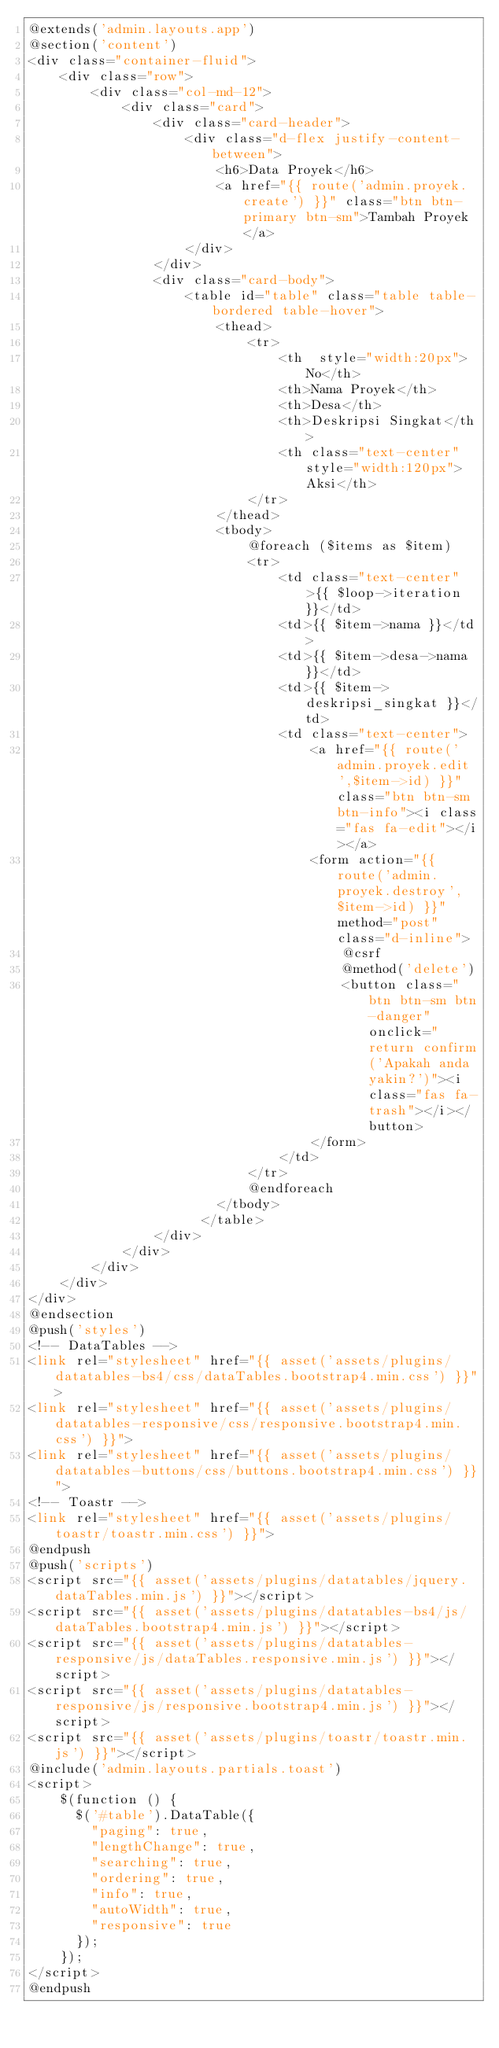Convert code to text. <code><loc_0><loc_0><loc_500><loc_500><_PHP_>@extends('admin.layouts.app')
@section('content')
<div class="container-fluid">
    <div class="row">
        <div class="col-md-12">
            <div class="card">
                <div class="card-header">
                    <div class="d-flex justify-content-between">
                        <h6>Data Proyek</h6>
                        <a href="{{ route('admin.proyek.create') }}" class="btn btn-primary btn-sm">Tambah Proyek</a>
                    </div>
                </div>
                <div class="card-body">
                    <table id="table" class="table table-bordered table-hover">
                        <thead>
                            <tr>
                                <th  style="width:20px">No</th>
                                <th>Nama Proyek</th>
                                <th>Desa</th>
                                <th>Deskripsi Singkat</th>
                                <th class="text-center" style="width:120px">Aksi</th>
                            </tr>
                        </thead>
                        <tbody>
                            @foreach ($items as $item)
                            <tr>
                                <td class="text-center">{{ $loop->iteration }}</td>
                                <td>{{ $item->nama }}</td>
                                <td>{{ $item->desa->nama }}</td>
                                <td>{{ $item->deskripsi_singkat }}</td>
                                <td class="text-center">
                                    <a href="{{ route('admin.proyek.edit',$item->id) }}" class="btn btn-sm btn-info"><i class="fas fa-edit"></i></a>
                                    <form action="{{ route('admin.proyek.destroy',$item->id) }}" method="post" class="d-inline">
                                        @csrf
                                        @method('delete')
                                        <button class="btn btn-sm btn-danger" onclick="return confirm('Apakah anda yakin?')"><i class="fas fa-trash"></i></button>
                                    </form>
                                </td>
                            </tr>
                            @endforeach
                        </tbody>
                      </table>
                </div>
            </div>
        </div>
    </div>
</div>
@endsection
@push('styles')
<!-- DataTables -->
<link rel="stylesheet" href="{{ asset('assets/plugins/datatables-bs4/css/dataTables.bootstrap4.min.css') }}">
<link rel="stylesheet" href="{{ asset('assets/plugins/datatables-responsive/css/responsive.bootstrap4.min.css') }}">
<link rel="stylesheet" href="{{ asset('assets/plugins/datatables-buttons/css/buttons.bootstrap4.min.css') }}">
<!-- Toastr -->
<link rel="stylesheet" href="{{ asset('assets/plugins/toastr/toastr.min.css') }}">
@endpush
@push('scripts')
<script src="{{ asset('assets/plugins/datatables/jquery.dataTables.min.js') }}"></script>
<script src="{{ asset('assets/plugins/datatables-bs4/js/dataTables.bootstrap4.min.js') }}"></script>
<script src="{{ asset('assets/plugins/datatables-responsive/js/dataTables.responsive.min.js') }}"></script>
<script src="{{ asset('assets/plugins/datatables-responsive/js/responsive.bootstrap4.min.js') }}"></script>
<script src="{{ asset('assets/plugins/toastr/toastr.min.js') }}"></script>
@include('admin.layouts.partials.toast')
<script>
    $(function () {
      $('#table').DataTable({
        "paging": true,
        "lengthChange": true,
        "searching": true,
        "ordering": true,
        "info": true,
        "autoWidth": true,
        "responsive": true
      });
    });
</script>
@endpush</code> 